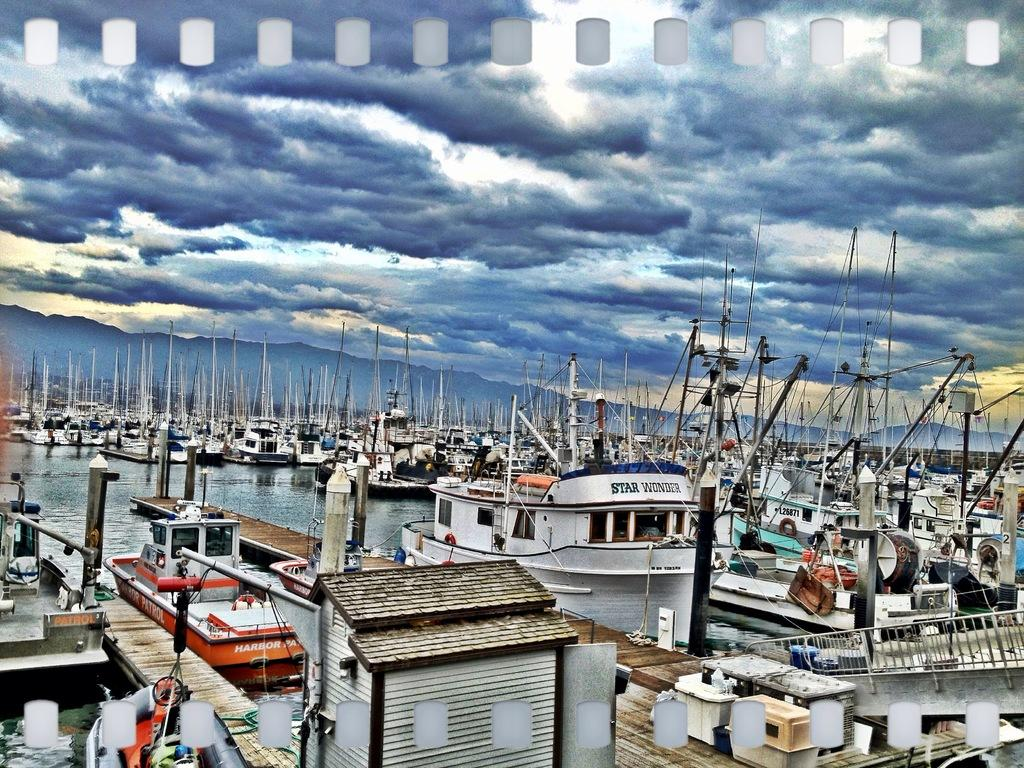What is the main subject in the center of the image? There are ships, poles, banners, and bags in the center of the image. What can be seen in the water in the image? The image only shows ships, poles, banners, and bags in the center of the image, and water visible around them. What is visible in the background of the image? The sky, clouds, and hills are visible in the background of the image. How does the glove help control the ships in the image? There is no glove present in the image, and therefore no such control can be observed. What is the comparison between the ships and the clouds in the image? The image does not provide any information for making a comparison between the ships and the clouds. 